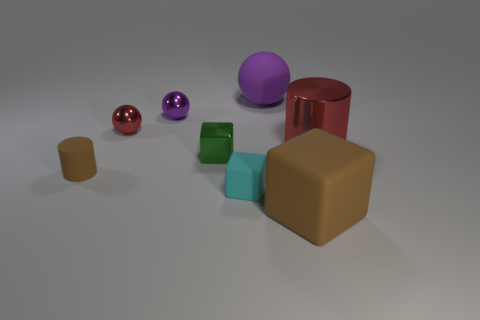Subtract all brown blocks. How many purple spheres are left? 2 Subtract all metallic cubes. How many cubes are left? 2 Subtract 1 cubes. How many cubes are left? 2 Add 2 big red shiny cylinders. How many objects exist? 10 Subtract all large green balls. Subtract all big purple balls. How many objects are left? 7 Add 7 small cyan rubber blocks. How many small cyan rubber blocks are left? 8 Add 1 tiny red shiny objects. How many tiny red shiny objects exist? 2 Subtract 0 yellow cylinders. How many objects are left? 8 Subtract all cubes. How many objects are left? 5 